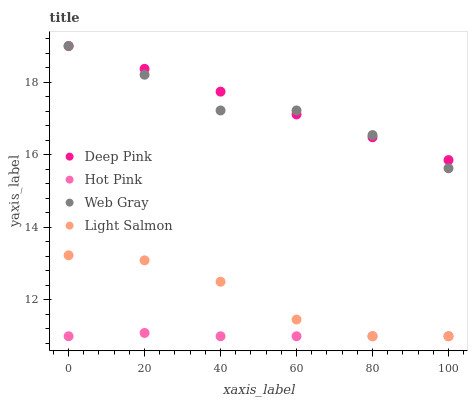Does Hot Pink have the minimum area under the curve?
Answer yes or no. Yes. Does Deep Pink have the maximum area under the curve?
Answer yes or no. Yes. Does Web Gray have the minimum area under the curve?
Answer yes or no. No. Does Web Gray have the maximum area under the curve?
Answer yes or no. No. Is Deep Pink the smoothest?
Answer yes or no. Yes. Is Web Gray the roughest?
Answer yes or no. Yes. Is Web Gray the smoothest?
Answer yes or no. No. Is Deep Pink the roughest?
Answer yes or no. No. Does Light Salmon have the lowest value?
Answer yes or no. Yes. Does Web Gray have the lowest value?
Answer yes or no. No. Does Web Gray have the highest value?
Answer yes or no. Yes. Does Hot Pink have the highest value?
Answer yes or no. No. Is Light Salmon less than Web Gray?
Answer yes or no. Yes. Is Deep Pink greater than Hot Pink?
Answer yes or no. Yes. Does Hot Pink intersect Light Salmon?
Answer yes or no. Yes. Is Hot Pink less than Light Salmon?
Answer yes or no. No. Is Hot Pink greater than Light Salmon?
Answer yes or no. No. Does Light Salmon intersect Web Gray?
Answer yes or no. No. 